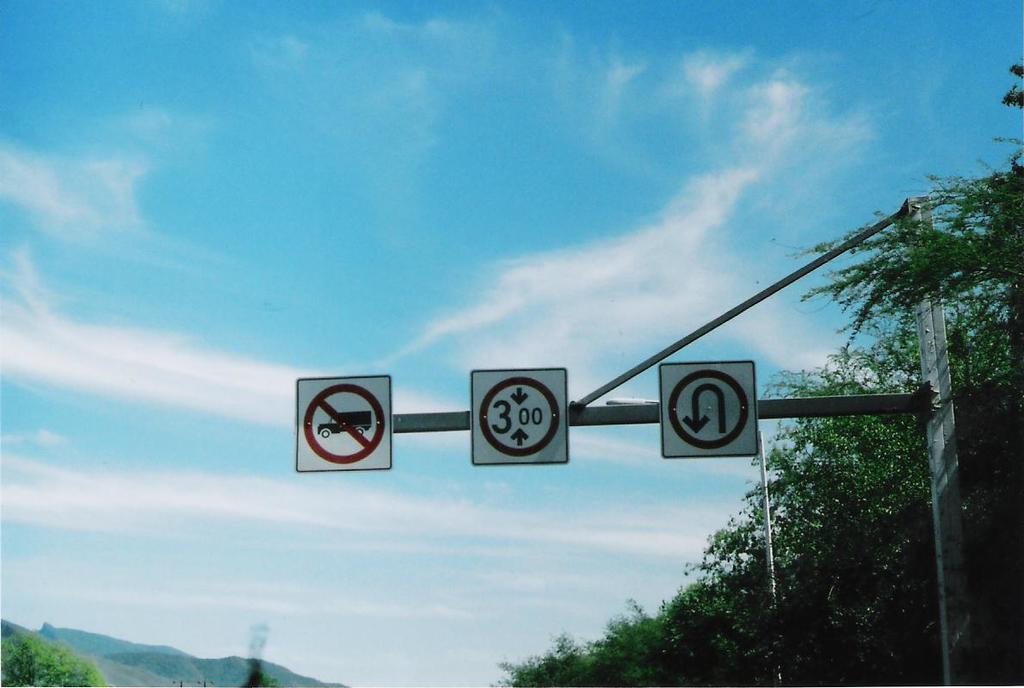<image>
Present a compact description of the photo's key features. three road signs on a pole, instructing that no trucks are allowed, vehicle can not be more than 3.00 and lastly no u turns are allowed 